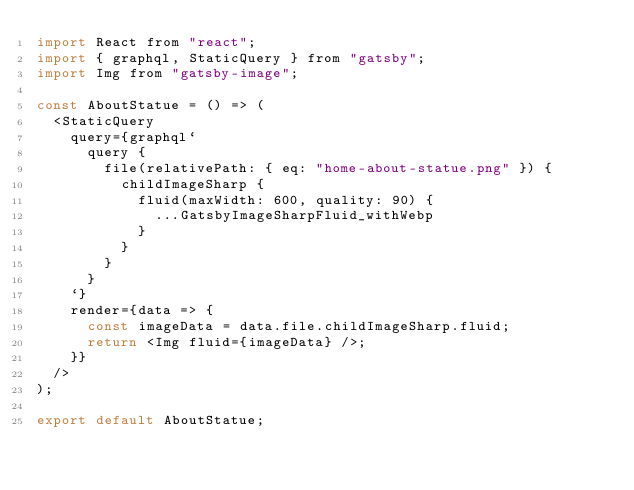<code> <loc_0><loc_0><loc_500><loc_500><_JavaScript_>import React from "react";
import { graphql, StaticQuery } from "gatsby";
import Img from "gatsby-image";

const AboutStatue = () => (
  <StaticQuery
    query={graphql`
      query {
        file(relativePath: { eq: "home-about-statue.png" }) {
          childImageSharp {
            fluid(maxWidth: 600, quality: 90) {
              ...GatsbyImageSharpFluid_withWebp
            }
          }
        }
      }
    `}
    render={data => {
      const imageData = data.file.childImageSharp.fluid;
      return <Img fluid={imageData} />;
    }}
  />
);

export default AboutStatue;
</code> 